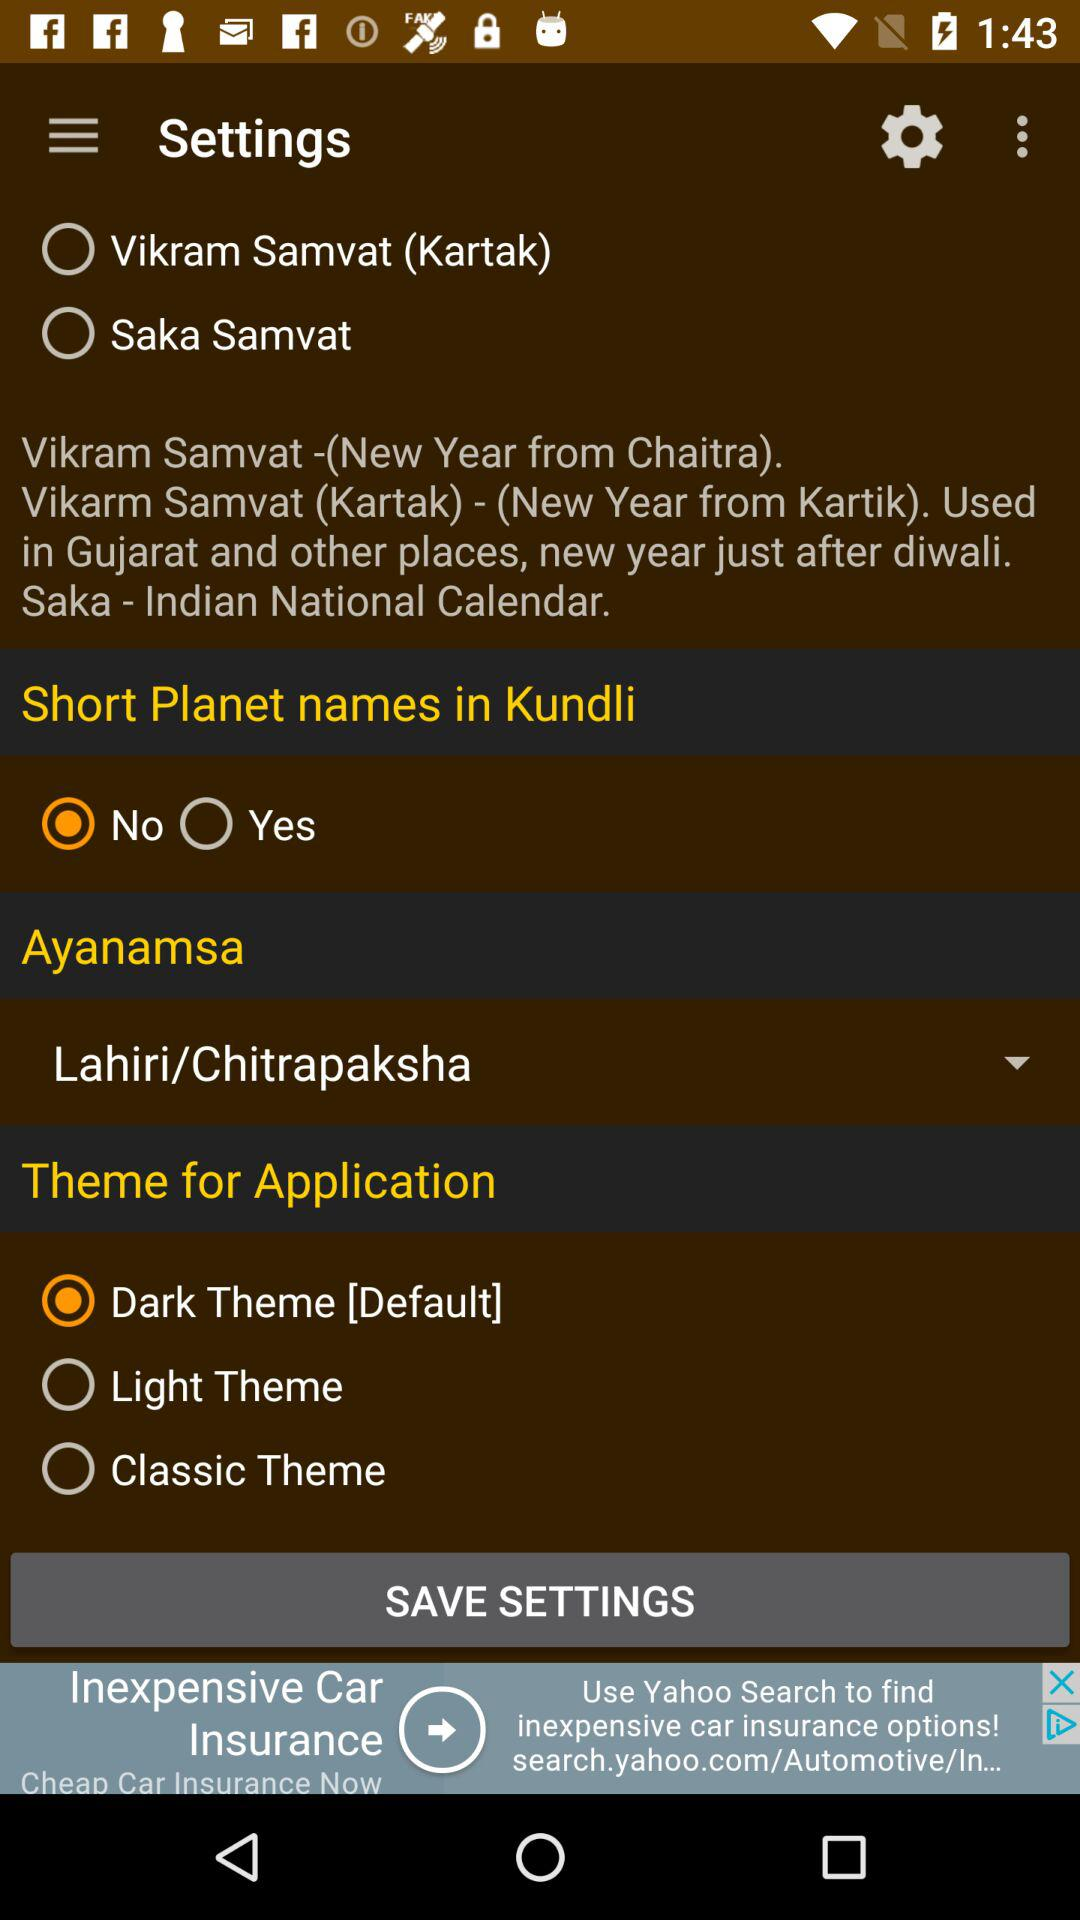What is the theme for the application? The theme for the application is "Dark Theme". 